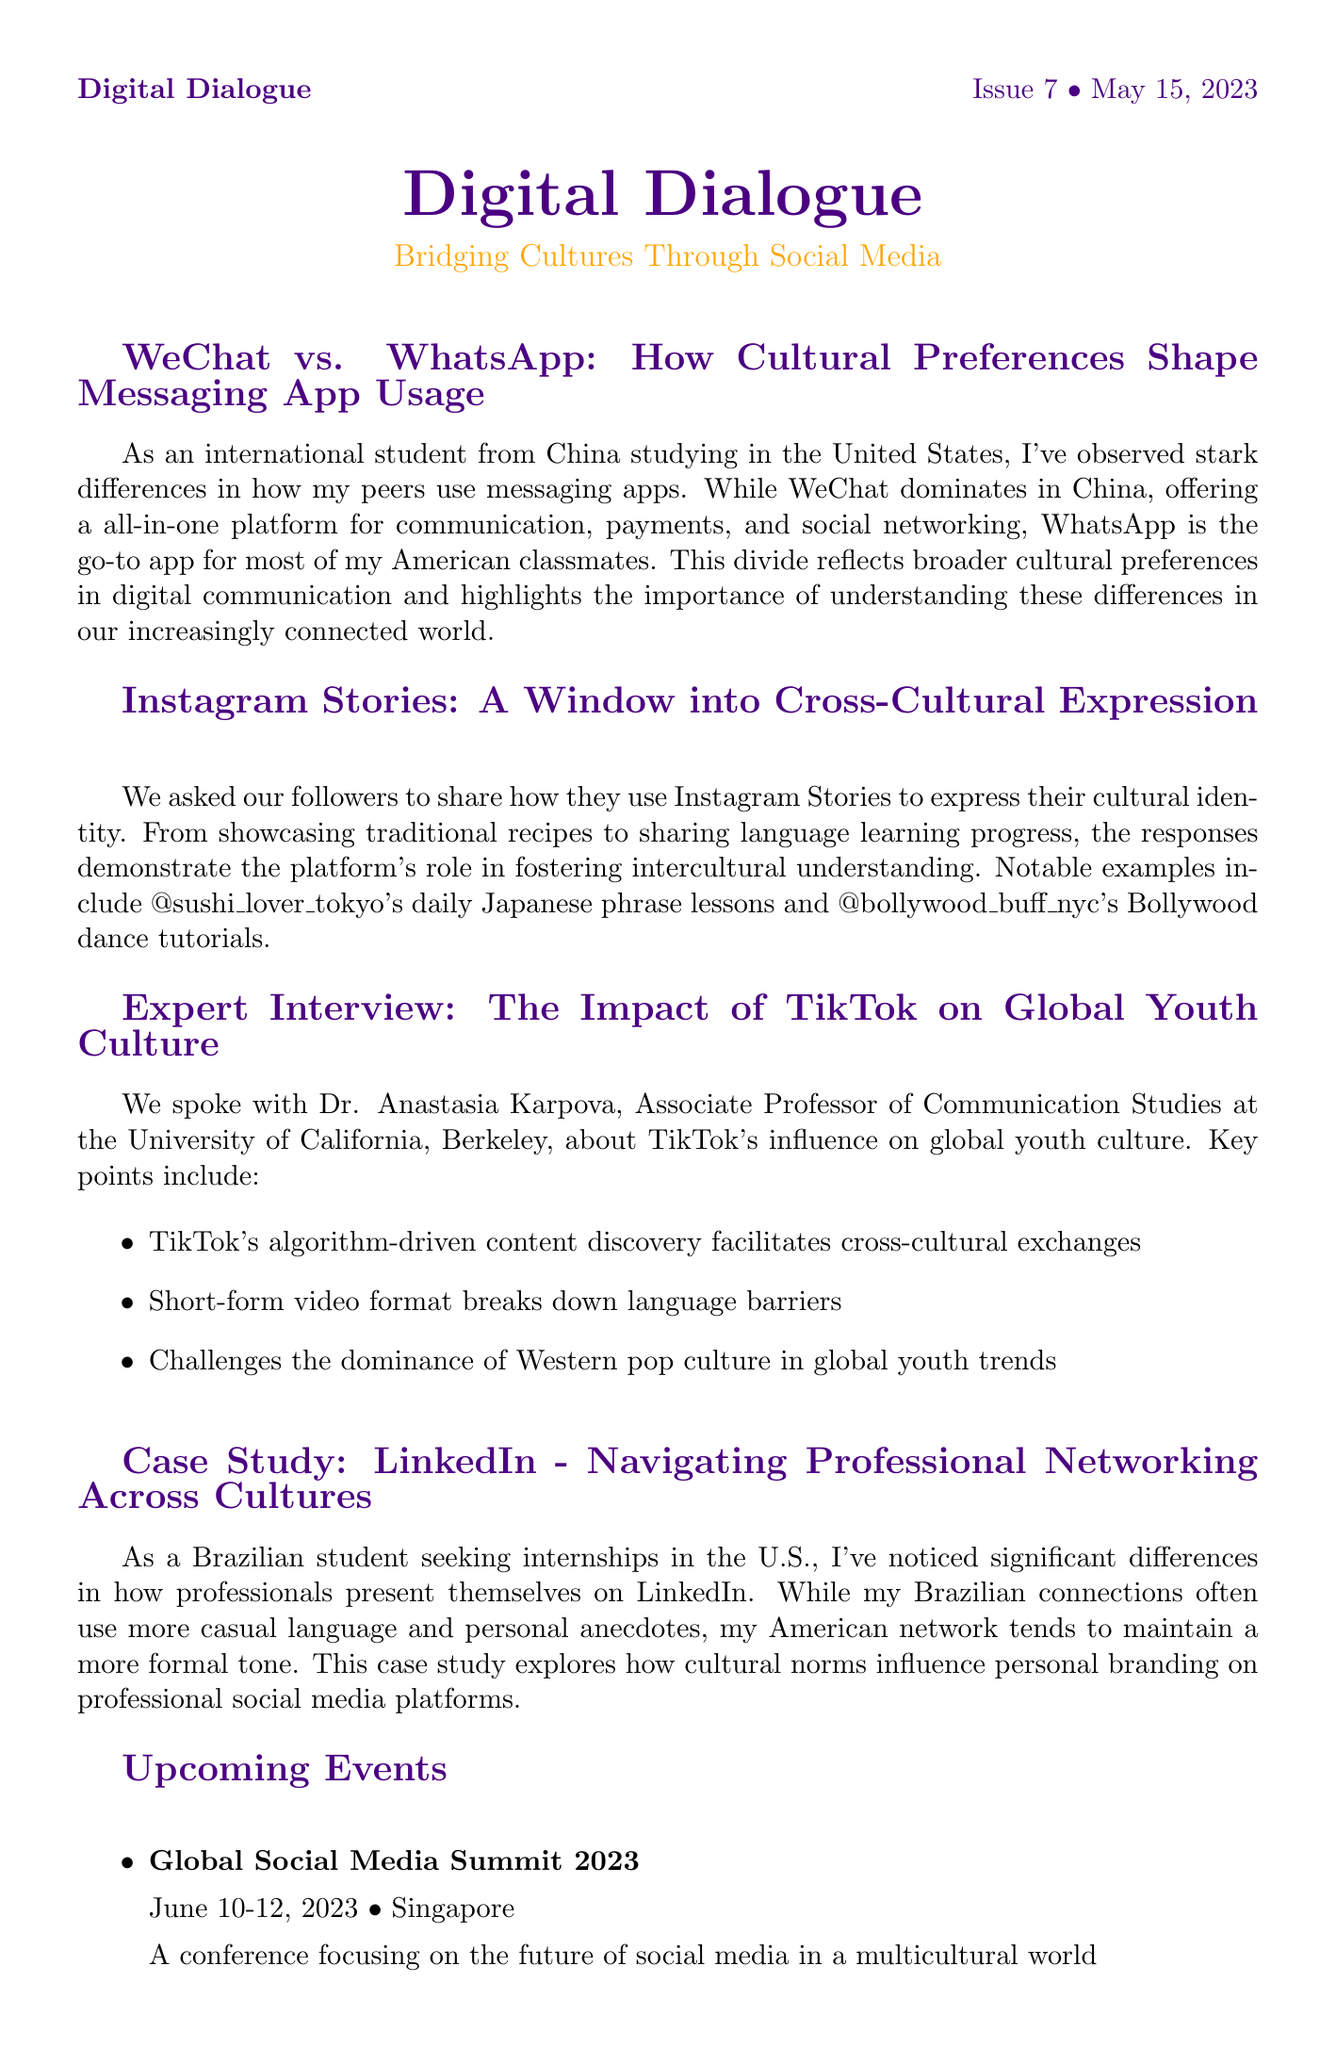what is the title of the main article? The title of the main article is the first section in the newsletter that discusses different messaging apps based on cultural preferences.
Answer: WeChat vs. WhatsApp: How Cultural Preferences Shape Messaging App Usage who is the expert interviewed in this newsletter? The expert interviewed is specifically named in the interview section which discusses their insights on TikTok's impact.
Answer: Dr. Anastasia Karpova what is the date of the upcoming Global Social Media Summit? The date of this event is listed under the upcoming events section in the document.
Answer: June 10-12, 2023 which social media platform is emphasized for cross-cultural expression in user-generated content? The platform highlighted in the user-generated content section where followers share cultural identities is mentioned.
Answer: Instagram Stories what publication year is associated with the resource spotlight? The publication year of the book in the resource spotlight section is clearly stated and helps in understanding the relevance of the book.
Answer: 2022 how many options are provided in the reader poll? The number of options can be counted in the reader poll section of the newsletter.
Answer: 5 what cultural norm difference is highlighted in the LinkedIn case study? The specific difference in professional presentation styles across cultures is outlined in the case study content.
Answer: Casual language vs. formal tone what is the title of the resource spotlight? The title of the resource spotlight provides an overview of the focus of the book being highlighted in the newsletter.
Answer: Cross-Cultural Communication in the Digital Age 